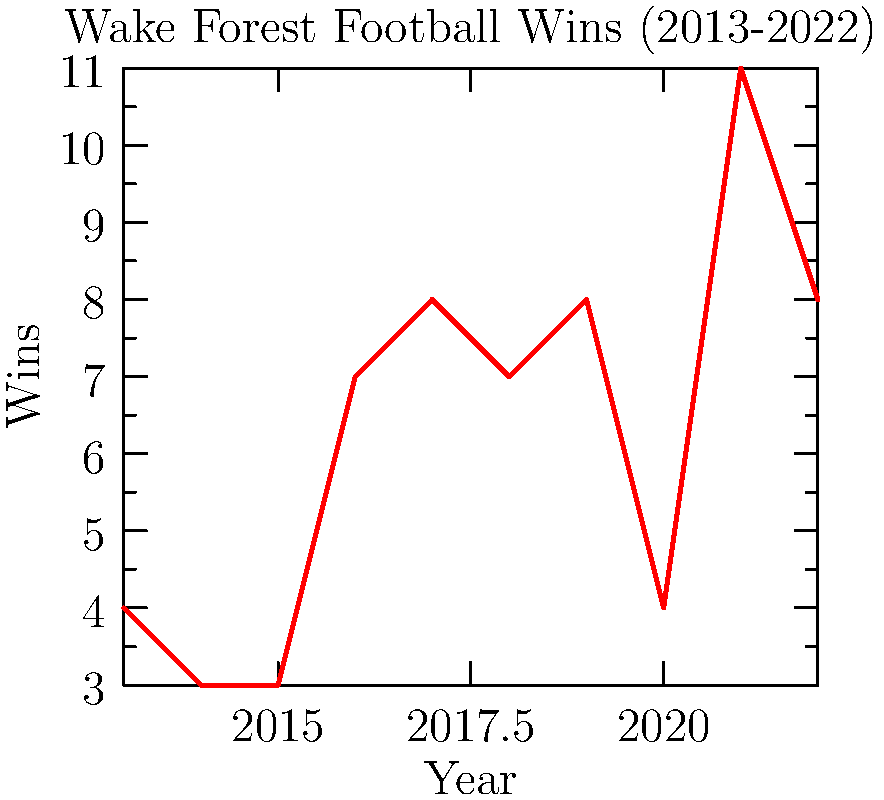Based on the line graph showing Wake Forest's football win record over the past decade, in which year did the Demon Deacons achieve their highest number of wins, and how many games did they win that season? To answer this question, we need to analyze the line graph carefully:

1. The x-axis represents the years from 2013 to 2022.
2. The y-axis represents the number of wins in each season.
3. We need to identify the highest point on the graph, which represents the season with the most wins.

Looking at the graph:
- The line starts relatively low in 2013-2015.
- There's a gradual increase from 2016 to 2019.
- There's a dip in 2020 (likely due to the COVID-19 pandemic).
- The highest point on the graph clearly occurs in 2021.
- The number of wins for 2021 appears to be 11.

Therefore, Wake Forest had their best season in the past decade in 2021, with 11 wins.
Answer: 2021, 11 wins 